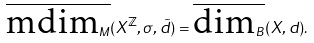Convert formula to latex. <formula><loc_0><loc_0><loc_500><loc_500>\overline { \text {mdim} _ { M } } ( X ^ { \mathbb { Z } } , \sigma , \tilde { d } ) = \overline { \text {dim} _ { B } } ( X , d ) .</formula> 